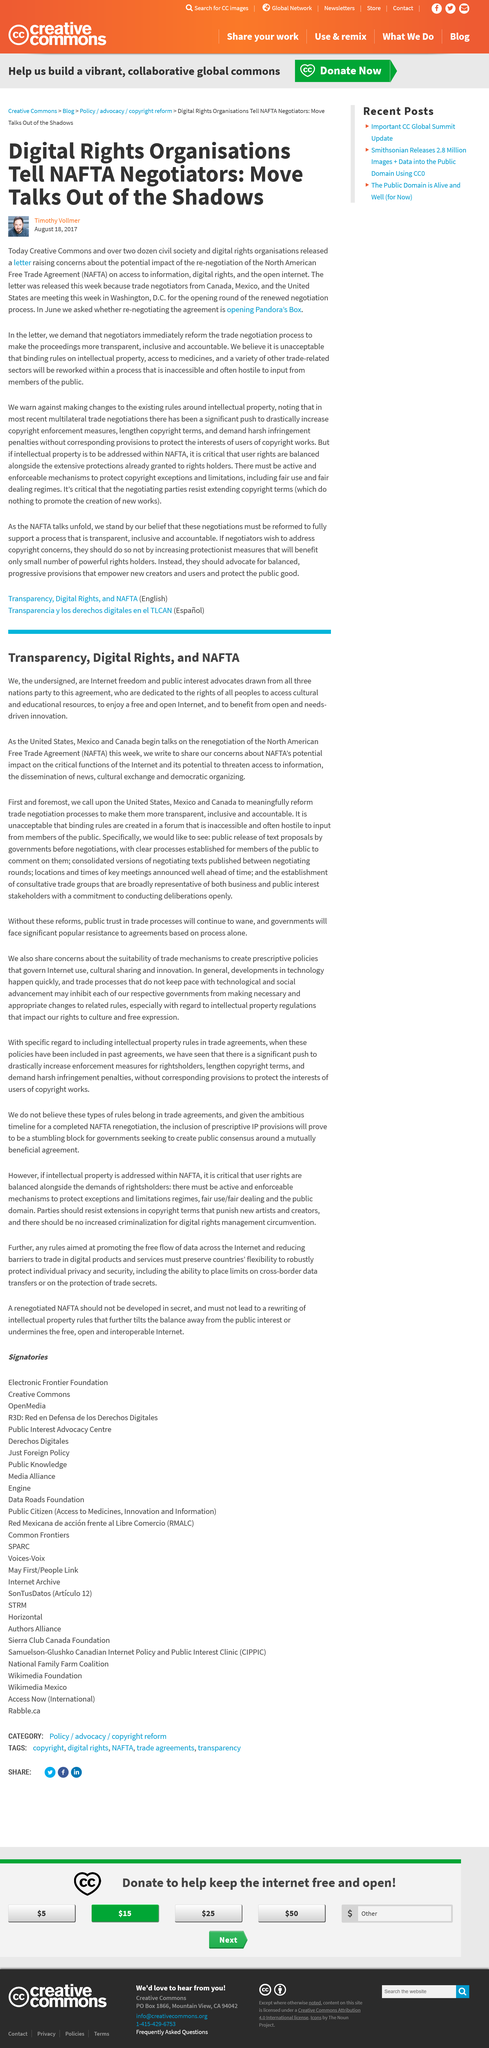Specify some key components in this picture. Timothy Vollmer likened the process of re-negotiating the agreement to opening Pandora's Box, indicating that it could have unintended consequences and potentially lead to disaster. The article was written by Timothy Vollmer and posted on August 18, 2017, by Timothy Vollmer. 